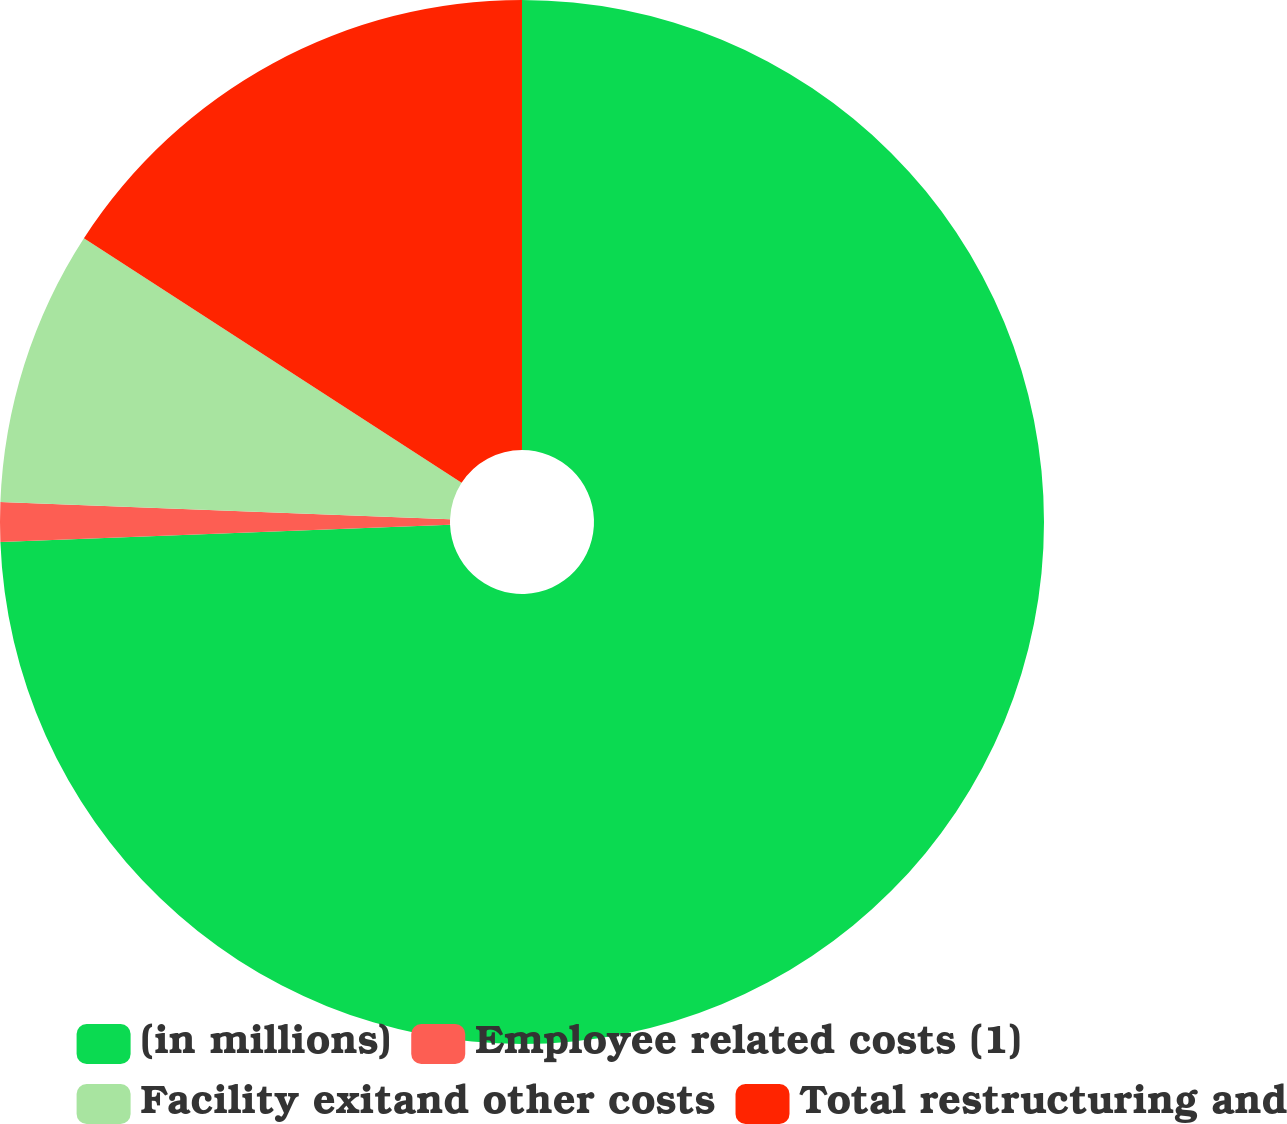<chart> <loc_0><loc_0><loc_500><loc_500><pie_chart><fcel>(in millions)<fcel>Employee related costs (1)<fcel>Facility exitand other costs<fcel>Total restructuring and<nl><fcel>74.39%<fcel>1.22%<fcel>8.54%<fcel>15.85%<nl></chart> 